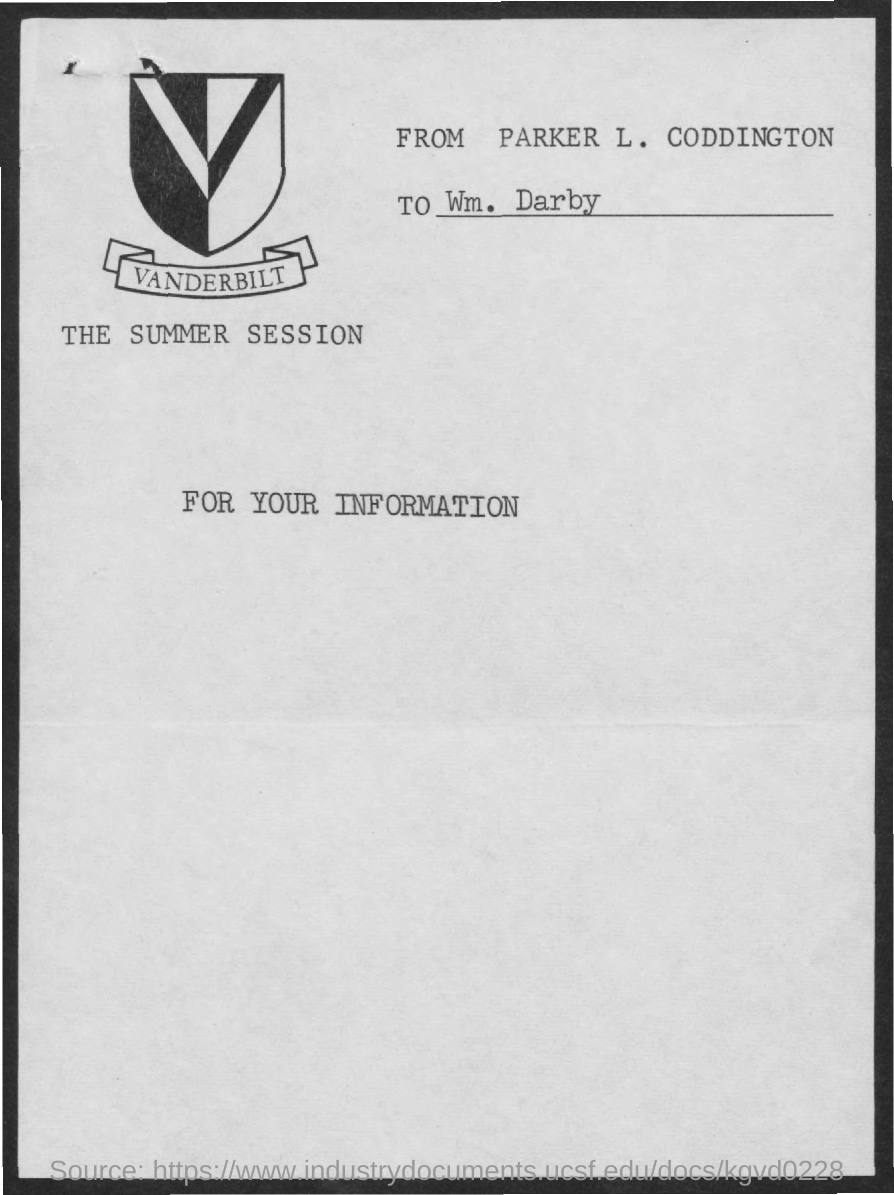Identify some key points in this picture. The image shown represents the icon of Vanderbilt University. The document is addressed to William Darby. The sender is Parker L. Coddington. 